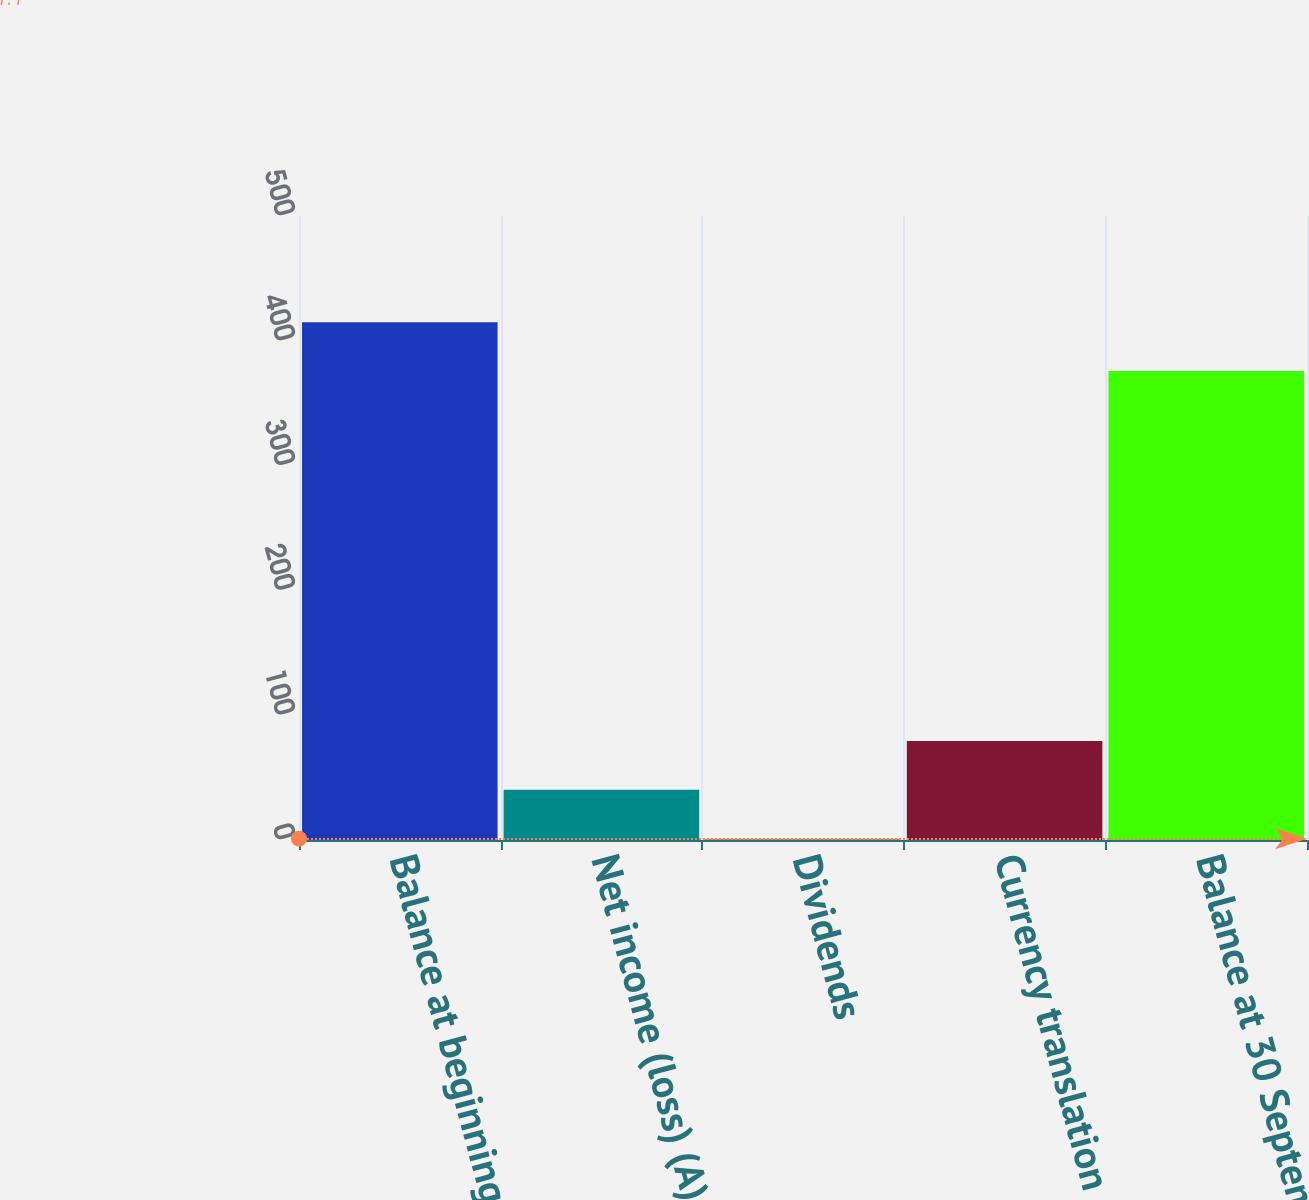<chart> <loc_0><loc_0><loc_500><loc_500><bar_chart><fcel>Balance at beginning of year<fcel>Net income (loss) (A)<fcel>Dividends<fcel>Currency translation<fcel>Balance at 30 September<nl><fcel>414.94<fcel>40.24<fcel>1.1<fcel>79.38<fcel>375.8<nl></chart> 